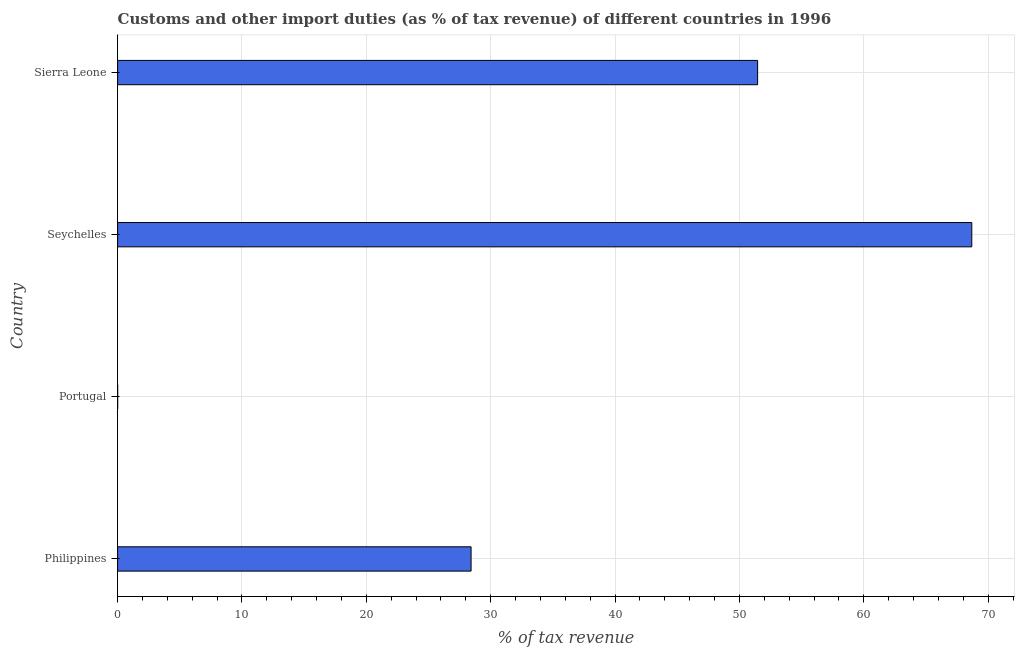Does the graph contain any zero values?
Provide a short and direct response. No. What is the title of the graph?
Your answer should be very brief. Customs and other import duties (as % of tax revenue) of different countries in 1996. What is the label or title of the X-axis?
Your answer should be compact. % of tax revenue. What is the label or title of the Y-axis?
Offer a very short reply. Country. What is the customs and other import duties in Seychelles?
Provide a short and direct response. 68.69. Across all countries, what is the maximum customs and other import duties?
Make the answer very short. 68.69. Across all countries, what is the minimum customs and other import duties?
Offer a terse response. 0. In which country was the customs and other import duties maximum?
Offer a terse response. Seychelles. What is the sum of the customs and other import duties?
Ensure brevity in your answer.  148.58. What is the difference between the customs and other import duties in Seychelles and Sierra Leone?
Keep it short and to the point. 17.22. What is the average customs and other import duties per country?
Give a very brief answer. 37.14. What is the median customs and other import duties?
Provide a succinct answer. 39.94. In how many countries, is the customs and other import duties greater than 6 %?
Your response must be concise. 3. What is the ratio of the customs and other import duties in Philippines to that in Portugal?
Ensure brevity in your answer.  6952.04. Is the customs and other import duties in Seychelles less than that in Sierra Leone?
Ensure brevity in your answer.  No. What is the difference between the highest and the second highest customs and other import duties?
Make the answer very short. 17.22. Is the sum of the customs and other import duties in Philippines and Sierra Leone greater than the maximum customs and other import duties across all countries?
Offer a terse response. Yes. What is the difference between the highest and the lowest customs and other import duties?
Ensure brevity in your answer.  68.68. How many bars are there?
Provide a succinct answer. 4. Are all the bars in the graph horizontal?
Your answer should be compact. Yes. What is the difference between two consecutive major ticks on the X-axis?
Provide a succinct answer. 10. Are the values on the major ticks of X-axis written in scientific E-notation?
Ensure brevity in your answer.  No. What is the % of tax revenue in Philippines?
Provide a succinct answer. 28.42. What is the % of tax revenue in Portugal?
Your answer should be compact. 0. What is the % of tax revenue of Seychelles?
Ensure brevity in your answer.  68.69. What is the % of tax revenue of Sierra Leone?
Offer a terse response. 51.46. What is the difference between the % of tax revenue in Philippines and Portugal?
Offer a very short reply. 28.42. What is the difference between the % of tax revenue in Philippines and Seychelles?
Your answer should be very brief. -40.26. What is the difference between the % of tax revenue in Philippines and Sierra Leone?
Your answer should be very brief. -23.04. What is the difference between the % of tax revenue in Portugal and Seychelles?
Offer a terse response. -68.68. What is the difference between the % of tax revenue in Portugal and Sierra Leone?
Offer a terse response. -51.46. What is the difference between the % of tax revenue in Seychelles and Sierra Leone?
Your answer should be very brief. 17.22. What is the ratio of the % of tax revenue in Philippines to that in Portugal?
Give a very brief answer. 6952.04. What is the ratio of the % of tax revenue in Philippines to that in Seychelles?
Offer a terse response. 0.41. What is the ratio of the % of tax revenue in Philippines to that in Sierra Leone?
Provide a succinct answer. 0.55. What is the ratio of the % of tax revenue in Portugal to that in Sierra Leone?
Offer a very short reply. 0. What is the ratio of the % of tax revenue in Seychelles to that in Sierra Leone?
Give a very brief answer. 1.33. 